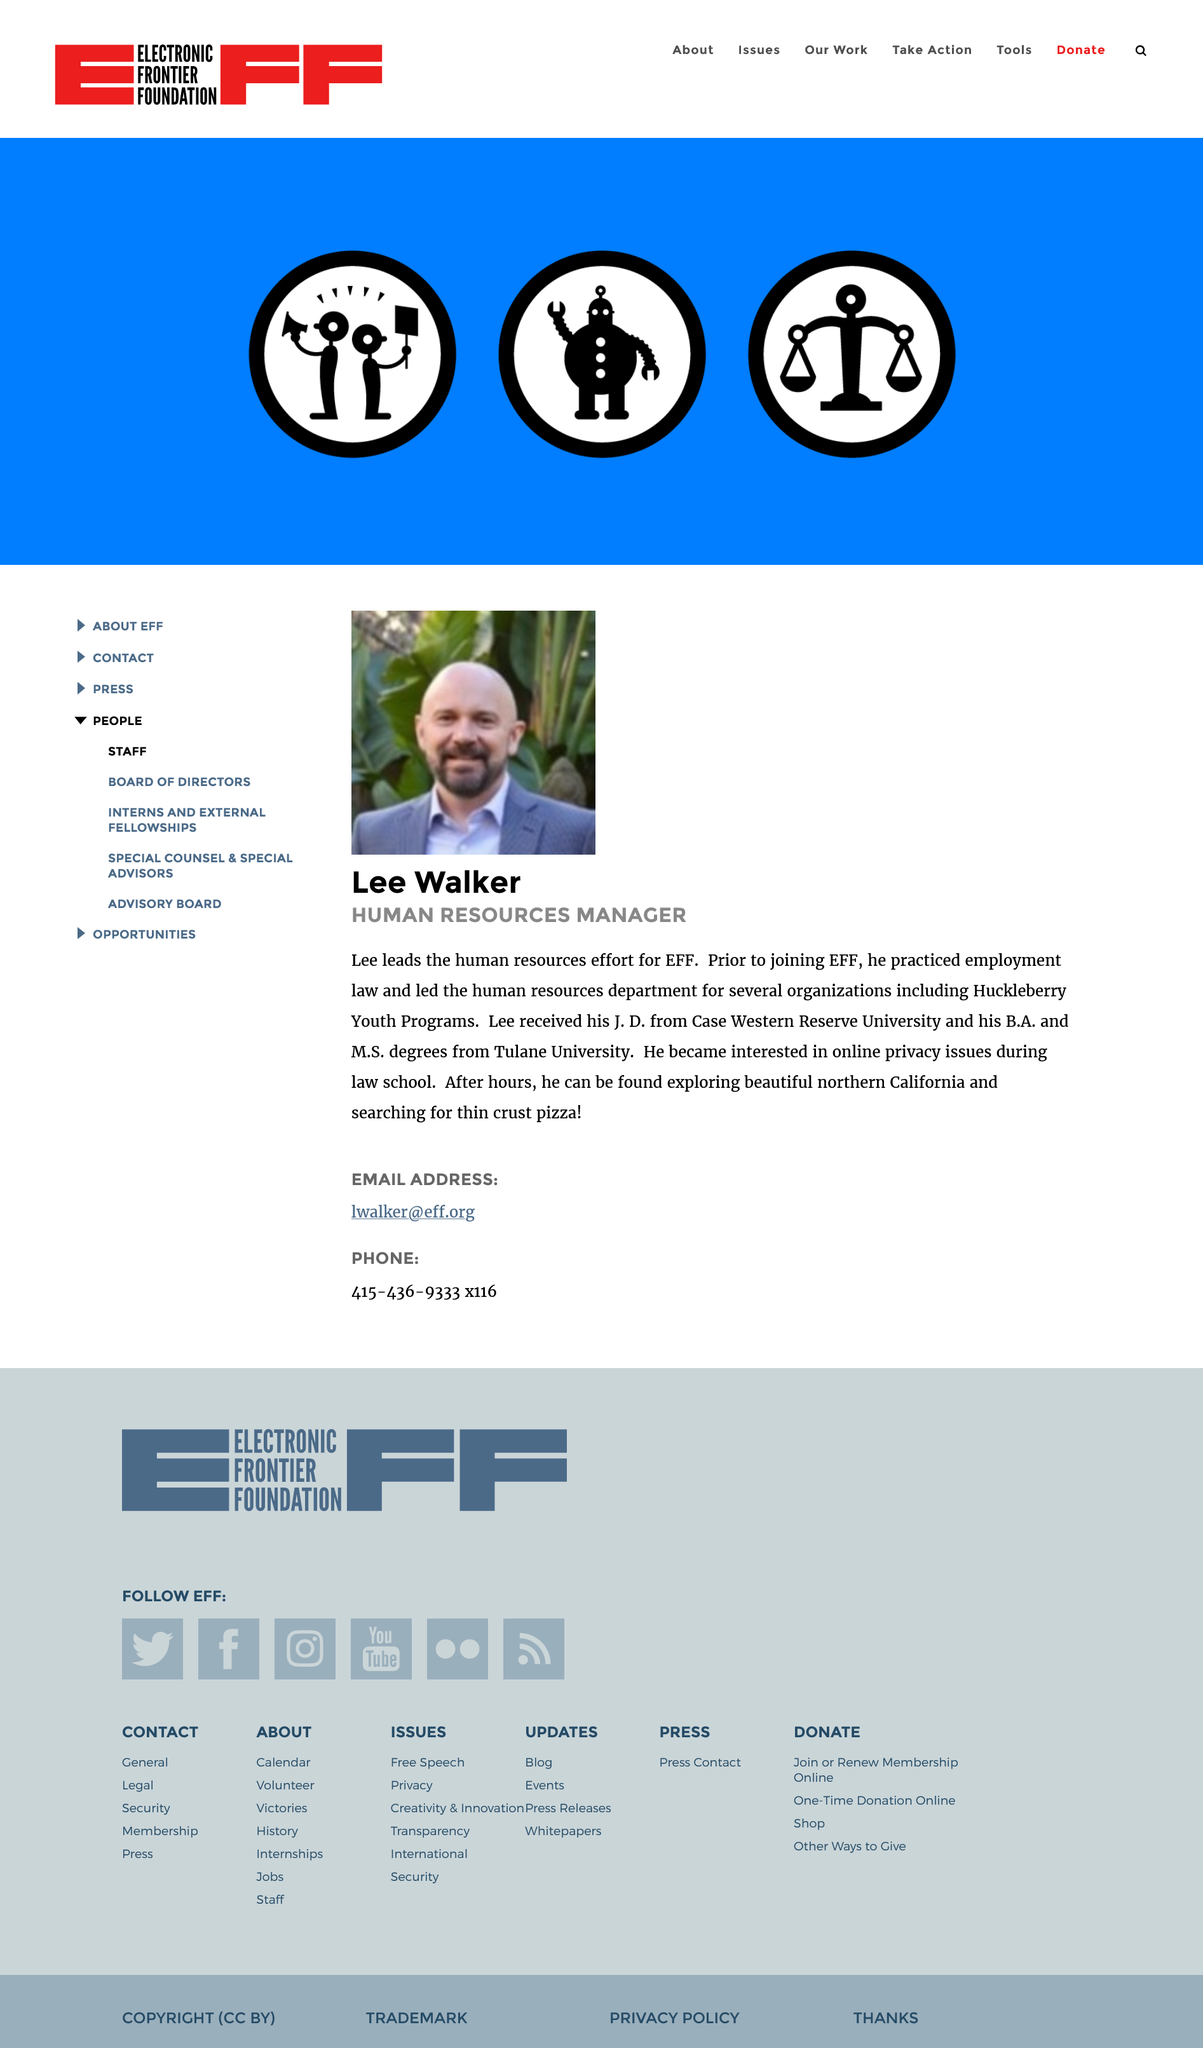Point out several critical features in this image. Lee Walker is the Human Resources Manager and in this position, he is responsible for managing the company's human resources. Lee Walker obtained his J.D. from Case Western Reserve University, I, Lee Walker, am frequently in search of thin crust pizza. 